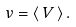<formula> <loc_0><loc_0><loc_500><loc_500>v = \langle \, V \, \rangle \, .</formula> 